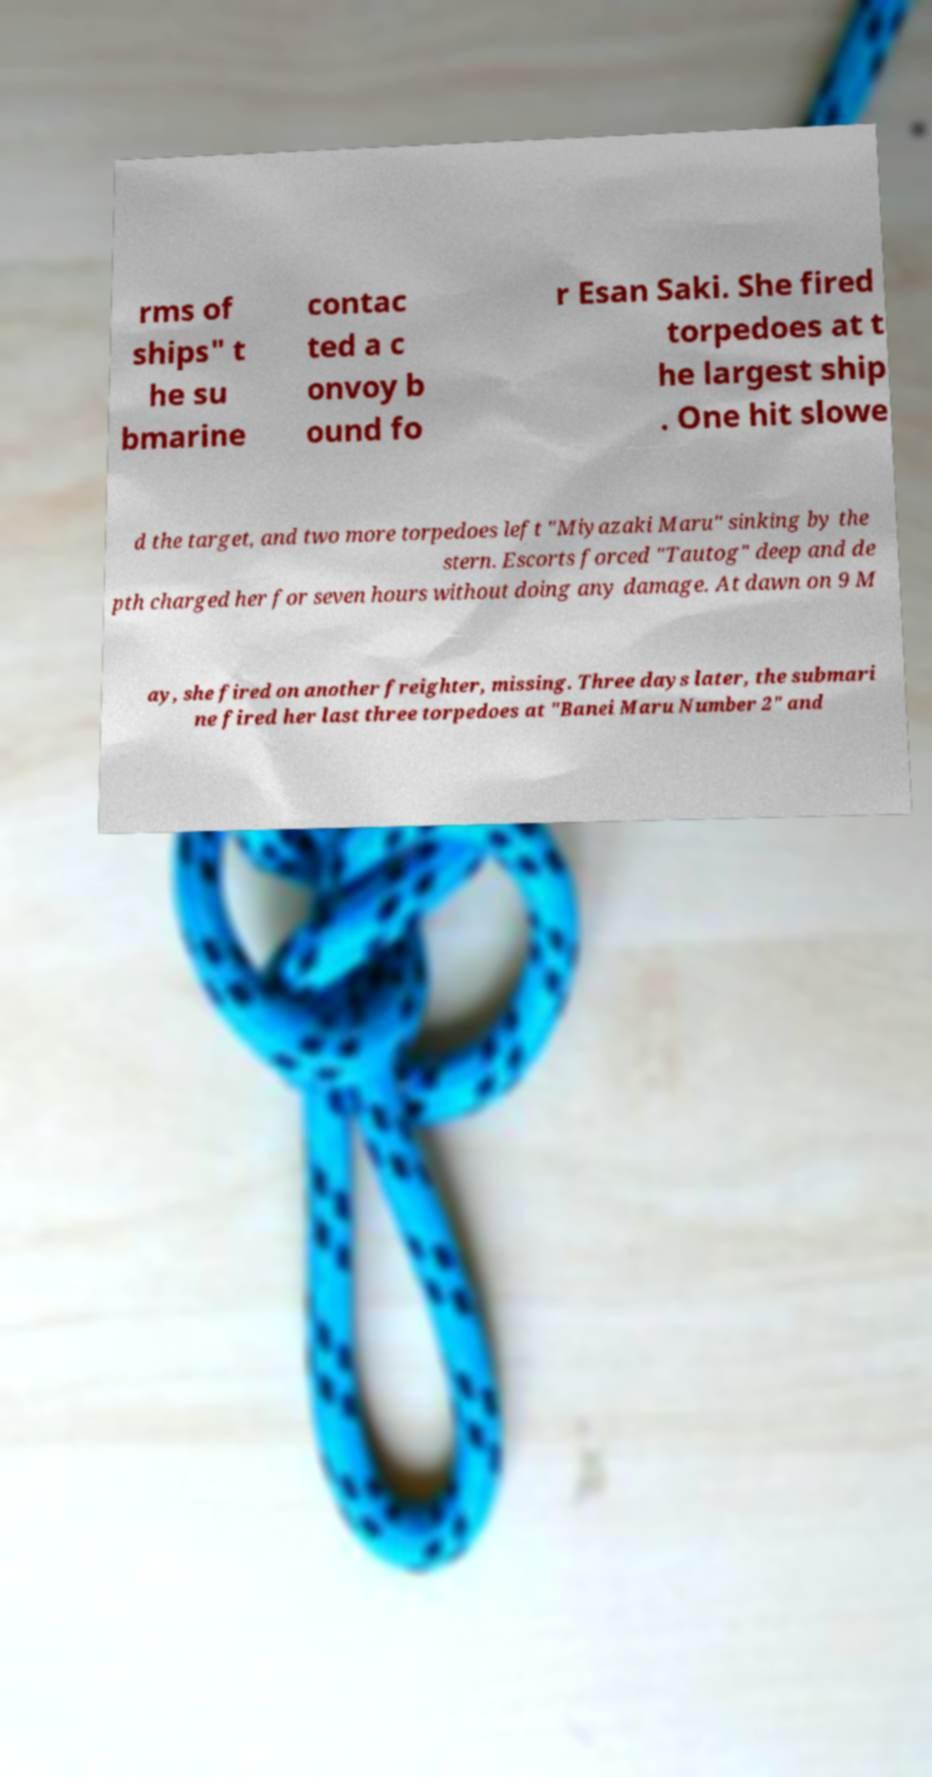Could you assist in decoding the text presented in this image and type it out clearly? rms of ships" t he su bmarine contac ted a c onvoy b ound fo r Esan Saki. She fired torpedoes at t he largest ship . One hit slowe d the target, and two more torpedoes left "Miyazaki Maru" sinking by the stern. Escorts forced "Tautog" deep and de pth charged her for seven hours without doing any damage. At dawn on 9 M ay, she fired on another freighter, missing. Three days later, the submari ne fired her last three torpedoes at "Banei Maru Number 2" and 